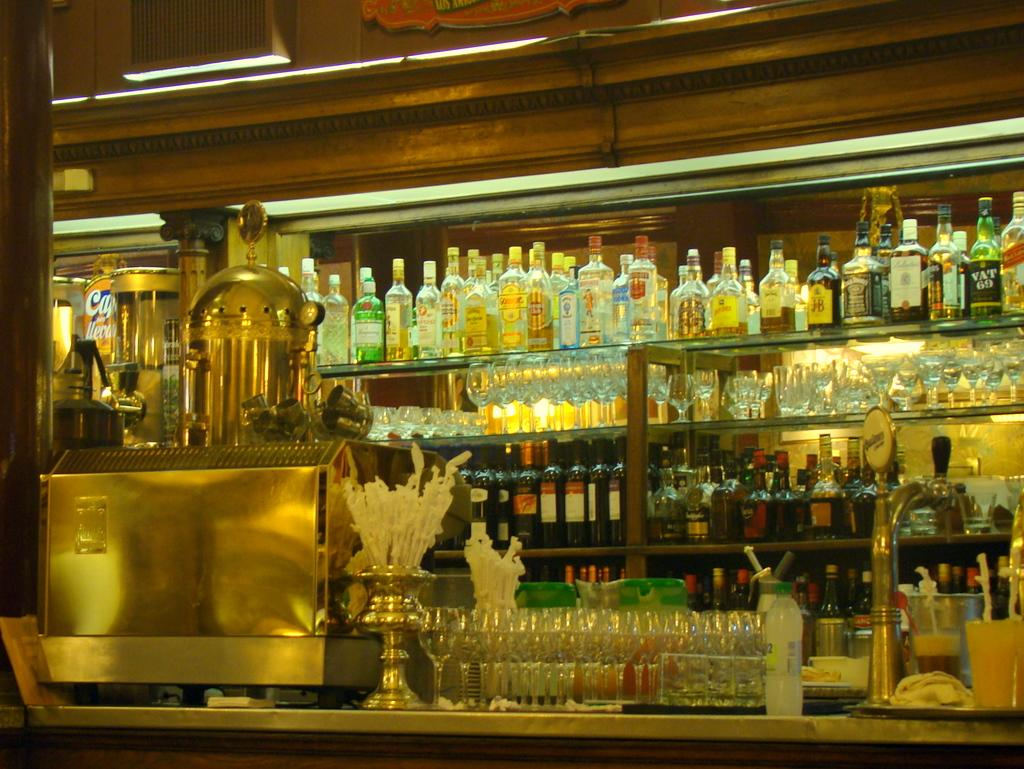What type of storage system is visible in the image? There are racks in the image. What items are stored on the racks? There are bottles and wine glasses on the racks. What type of bells can be heard ringing in the image? There are no bells present in the image, and therefore no sound can be heard. 